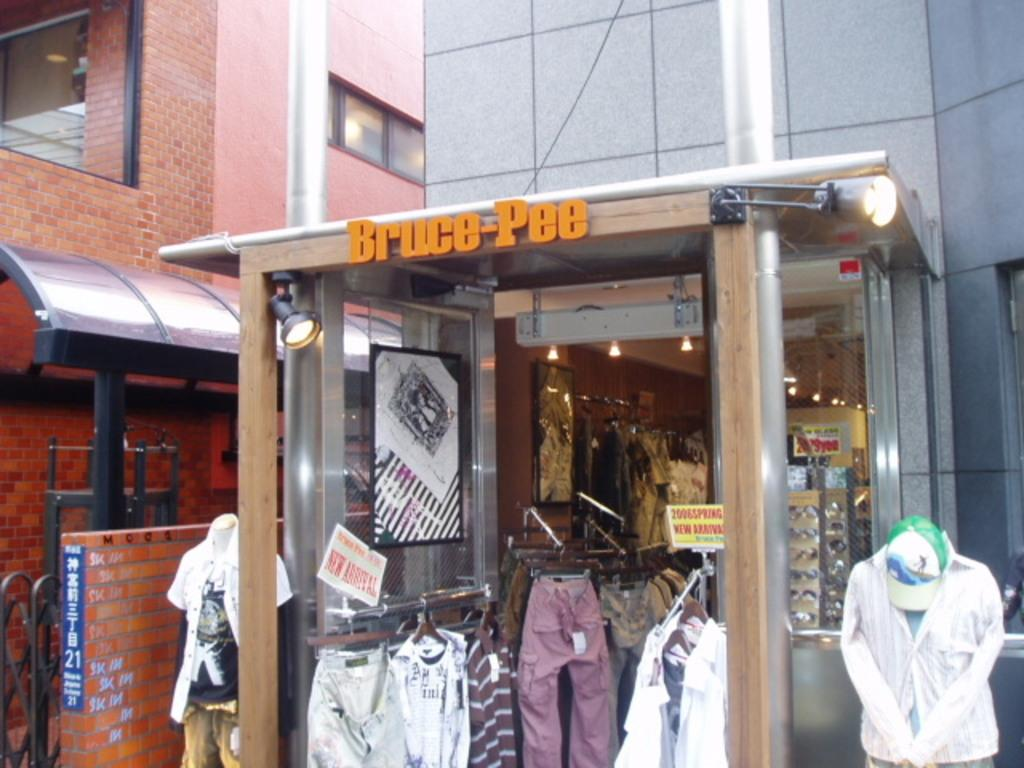Provide a one-sentence caption for the provided image. A store front for Bruce Pee with clothes in the entrance. 